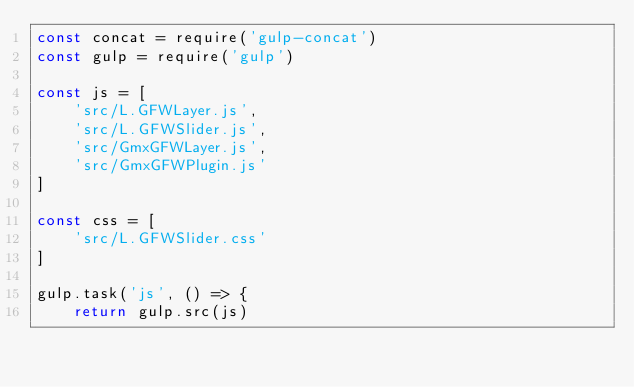Convert code to text. <code><loc_0><loc_0><loc_500><loc_500><_JavaScript_>const concat = require('gulp-concat')
const gulp = require('gulp')

const js = [
    'src/L.GFWLayer.js',
    'src/L.GFWSlider.js',
    'src/GmxGFWLayer.js',
    'src/GmxGFWPlugin.js'
]

const css = [
    'src/L.GFWSlider.css'
]

gulp.task('js', () => {
    return gulp.src(js)</code> 